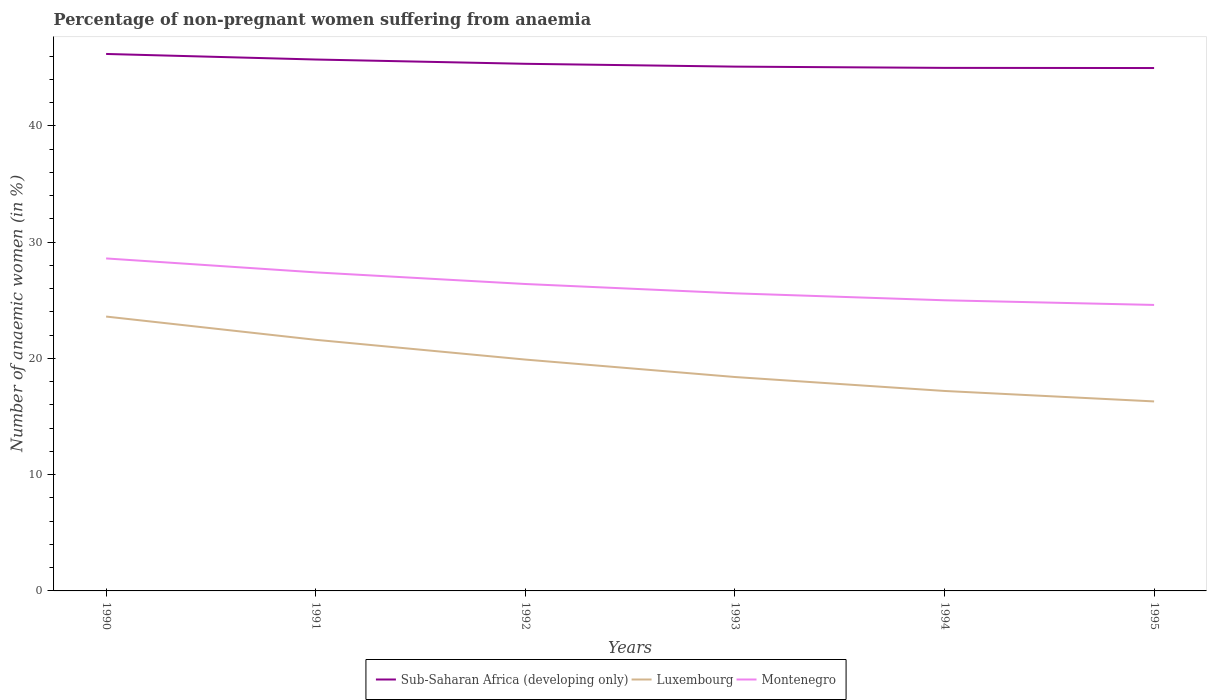Does the line corresponding to Luxembourg intersect with the line corresponding to Sub-Saharan Africa (developing only)?
Offer a terse response. No. Is the number of lines equal to the number of legend labels?
Keep it short and to the point. Yes. Across all years, what is the maximum percentage of non-pregnant women suffering from anaemia in Montenegro?
Ensure brevity in your answer.  24.6. What is the total percentage of non-pregnant women suffering from anaemia in Sub-Saharan Africa (developing only) in the graph?
Your answer should be compact. 0.35. What is the difference between the highest and the second highest percentage of non-pregnant women suffering from anaemia in Sub-Saharan Africa (developing only)?
Your answer should be very brief. 1.21. Is the percentage of non-pregnant women suffering from anaemia in Luxembourg strictly greater than the percentage of non-pregnant women suffering from anaemia in Montenegro over the years?
Your response must be concise. Yes. How many lines are there?
Your answer should be very brief. 3. Does the graph contain any zero values?
Keep it short and to the point. No. Does the graph contain grids?
Make the answer very short. No. Where does the legend appear in the graph?
Give a very brief answer. Bottom center. What is the title of the graph?
Offer a terse response. Percentage of non-pregnant women suffering from anaemia. What is the label or title of the Y-axis?
Offer a very short reply. Number of anaemic women (in %). What is the Number of anaemic women (in %) in Sub-Saharan Africa (developing only) in 1990?
Provide a succinct answer. 46.19. What is the Number of anaemic women (in %) in Luxembourg in 1990?
Offer a very short reply. 23.6. What is the Number of anaemic women (in %) of Montenegro in 1990?
Make the answer very short. 28.6. What is the Number of anaemic women (in %) of Sub-Saharan Africa (developing only) in 1991?
Provide a short and direct response. 45.71. What is the Number of anaemic women (in %) in Luxembourg in 1991?
Provide a succinct answer. 21.6. What is the Number of anaemic women (in %) in Montenegro in 1991?
Provide a short and direct response. 27.4. What is the Number of anaemic women (in %) in Sub-Saharan Africa (developing only) in 1992?
Keep it short and to the point. 45.34. What is the Number of anaemic women (in %) of Montenegro in 1992?
Your response must be concise. 26.4. What is the Number of anaemic women (in %) in Sub-Saharan Africa (developing only) in 1993?
Keep it short and to the point. 45.1. What is the Number of anaemic women (in %) of Luxembourg in 1993?
Ensure brevity in your answer.  18.4. What is the Number of anaemic women (in %) of Montenegro in 1993?
Keep it short and to the point. 25.6. What is the Number of anaemic women (in %) of Sub-Saharan Africa (developing only) in 1994?
Provide a short and direct response. 44.99. What is the Number of anaemic women (in %) in Sub-Saharan Africa (developing only) in 1995?
Offer a very short reply. 44.98. What is the Number of anaemic women (in %) of Luxembourg in 1995?
Keep it short and to the point. 16.3. What is the Number of anaemic women (in %) in Montenegro in 1995?
Provide a short and direct response. 24.6. Across all years, what is the maximum Number of anaemic women (in %) in Sub-Saharan Africa (developing only)?
Your answer should be compact. 46.19. Across all years, what is the maximum Number of anaemic women (in %) in Luxembourg?
Offer a terse response. 23.6. Across all years, what is the maximum Number of anaemic women (in %) of Montenegro?
Provide a succinct answer. 28.6. Across all years, what is the minimum Number of anaemic women (in %) in Sub-Saharan Africa (developing only)?
Provide a short and direct response. 44.98. Across all years, what is the minimum Number of anaemic women (in %) of Montenegro?
Keep it short and to the point. 24.6. What is the total Number of anaemic women (in %) of Sub-Saharan Africa (developing only) in the graph?
Provide a short and direct response. 272.31. What is the total Number of anaemic women (in %) in Luxembourg in the graph?
Offer a terse response. 117. What is the total Number of anaemic women (in %) of Montenegro in the graph?
Your answer should be very brief. 157.6. What is the difference between the Number of anaemic women (in %) in Sub-Saharan Africa (developing only) in 1990 and that in 1991?
Your answer should be very brief. 0.48. What is the difference between the Number of anaemic women (in %) of Luxembourg in 1990 and that in 1991?
Provide a succinct answer. 2. What is the difference between the Number of anaemic women (in %) in Montenegro in 1990 and that in 1991?
Offer a terse response. 1.2. What is the difference between the Number of anaemic women (in %) in Sub-Saharan Africa (developing only) in 1990 and that in 1992?
Your response must be concise. 0.85. What is the difference between the Number of anaemic women (in %) of Luxembourg in 1990 and that in 1992?
Keep it short and to the point. 3.7. What is the difference between the Number of anaemic women (in %) in Sub-Saharan Africa (developing only) in 1990 and that in 1993?
Your response must be concise. 1.09. What is the difference between the Number of anaemic women (in %) in Luxembourg in 1990 and that in 1993?
Give a very brief answer. 5.2. What is the difference between the Number of anaemic women (in %) in Montenegro in 1990 and that in 1993?
Your answer should be very brief. 3. What is the difference between the Number of anaemic women (in %) of Sub-Saharan Africa (developing only) in 1990 and that in 1994?
Provide a succinct answer. 1.2. What is the difference between the Number of anaemic women (in %) of Montenegro in 1990 and that in 1994?
Offer a very short reply. 3.6. What is the difference between the Number of anaemic women (in %) of Sub-Saharan Africa (developing only) in 1990 and that in 1995?
Your response must be concise. 1.21. What is the difference between the Number of anaemic women (in %) in Luxembourg in 1990 and that in 1995?
Provide a succinct answer. 7.3. What is the difference between the Number of anaemic women (in %) of Sub-Saharan Africa (developing only) in 1991 and that in 1992?
Give a very brief answer. 0.37. What is the difference between the Number of anaemic women (in %) of Sub-Saharan Africa (developing only) in 1991 and that in 1993?
Offer a terse response. 0.61. What is the difference between the Number of anaemic women (in %) in Luxembourg in 1991 and that in 1993?
Give a very brief answer. 3.2. What is the difference between the Number of anaemic women (in %) in Montenegro in 1991 and that in 1993?
Provide a short and direct response. 1.8. What is the difference between the Number of anaemic women (in %) in Sub-Saharan Africa (developing only) in 1991 and that in 1994?
Your response must be concise. 0.72. What is the difference between the Number of anaemic women (in %) of Luxembourg in 1991 and that in 1994?
Your answer should be compact. 4.4. What is the difference between the Number of anaemic women (in %) in Sub-Saharan Africa (developing only) in 1991 and that in 1995?
Your answer should be very brief. 0.73. What is the difference between the Number of anaemic women (in %) in Luxembourg in 1991 and that in 1995?
Offer a very short reply. 5.3. What is the difference between the Number of anaemic women (in %) in Sub-Saharan Africa (developing only) in 1992 and that in 1993?
Your answer should be compact. 0.24. What is the difference between the Number of anaemic women (in %) of Sub-Saharan Africa (developing only) in 1992 and that in 1994?
Offer a very short reply. 0.35. What is the difference between the Number of anaemic women (in %) of Luxembourg in 1992 and that in 1994?
Keep it short and to the point. 2.7. What is the difference between the Number of anaemic women (in %) in Montenegro in 1992 and that in 1994?
Your answer should be very brief. 1.4. What is the difference between the Number of anaemic women (in %) in Sub-Saharan Africa (developing only) in 1992 and that in 1995?
Provide a short and direct response. 0.36. What is the difference between the Number of anaemic women (in %) in Sub-Saharan Africa (developing only) in 1993 and that in 1994?
Ensure brevity in your answer.  0.11. What is the difference between the Number of anaemic women (in %) in Luxembourg in 1993 and that in 1994?
Ensure brevity in your answer.  1.2. What is the difference between the Number of anaemic women (in %) of Sub-Saharan Africa (developing only) in 1993 and that in 1995?
Your response must be concise. 0.12. What is the difference between the Number of anaemic women (in %) of Luxembourg in 1993 and that in 1995?
Provide a succinct answer. 2.1. What is the difference between the Number of anaemic women (in %) in Montenegro in 1993 and that in 1995?
Your answer should be compact. 1. What is the difference between the Number of anaemic women (in %) of Sub-Saharan Africa (developing only) in 1994 and that in 1995?
Ensure brevity in your answer.  0.01. What is the difference between the Number of anaemic women (in %) of Montenegro in 1994 and that in 1995?
Provide a succinct answer. 0.4. What is the difference between the Number of anaemic women (in %) of Sub-Saharan Africa (developing only) in 1990 and the Number of anaemic women (in %) of Luxembourg in 1991?
Offer a terse response. 24.59. What is the difference between the Number of anaemic women (in %) in Sub-Saharan Africa (developing only) in 1990 and the Number of anaemic women (in %) in Montenegro in 1991?
Make the answer very short. 18.79. What is the difference between the Number of anaemic women (in %) of Luxembourg in 1990 and the Number of anaemic women (in %) of Montenegro in 1991?
Your answer should be very brief. -3.8. What is the difference between the Number of anaemic women (in %) of Sub-Saharan Africa (developing only) in 1990 and the Number of anaemic women (in %) of Luxembourg in 1992?
Give a very brief answer. 26.29. What is the difference between the Number of anaemic women (in %) of Sub-Saharan Africa (developing only) in 1990 and the Number of anaemic women (in %) of Montenegro in 1992?
Make the answer very short. 19.79. What is the difference between the Number of anaemic women (in %) of Luxembourg in 1990 and the Number of anaemic women (in %) of Montenegro in 1992?
Your response must be concise. -2.8. What is the difference between the Number of anaemic women (in %) in Sub-Saharan Africa (developing only) in 1990 and the Number of anaemic women (in %) in Luxembourg in 1993?
Offer a very short reply. 27.79. What is the difference between the Number of anaemic women (in %) in Sub-Saharan Africa (developing only) in 1990 and the Number of anaemic women (in %) in Montenegro in 1993?
Your response must be concise. 20.59. What is the difference between the Number of anaemic women (in %) of Sub-Saharan Africa (developing only) in 1990 and the Number of anaemic women (in %) of Luxembourg in 1994?
Ensure brevity in your answer.  28.99. What is the difference between the Number of anaemic women (in %) of Sub-Saharan Africa (developing only) in 1990 and the Number of anaemic women (in %) of Montenegro in 1994?
Your response must be concise. 21.19. What is the difference between the Number of anaemic women (in %) in Sub-Saharan Africa (developing only) in 1990 and the Number of anaemic women (in %) in Luxembourg in 1995?
Provide a short and direct response. 29.89. What is the difference between the Number of anaemic women (in %) in Sub-Saharan Africa (developing only) in 1990 and the Number of anaemic women (in %) in Montenegro in 1995?
Provide a succinct answer. 21.59. What is the difference between the Number of anaemic women (in %) of Luxembourg in 1990 and the Number of anaemic women (in %) of Montenegro in 1995?
Your answer should be compact. -1. What is the difference between the Number of anaemic women (in %) in Sub-Saharan Africa (developing only) in 1991 and the Number of anaemic women (in %) in Luxembourg in 1992?
Your answer should be compact. 25.81. What is the difference between the Number of anaemic women (in %) in Sub-Saharan Africa (developing only) in 1991 and the Number of anaemic women (in %) in Montenegro in 1992?
Offer a very short reply. 19.31. What is the difference between the Number of anaemic women (in %) in Luxembourg in 1991 and the Number of anaemic women (in %) in Montenegro in 1992?
Your answer should be very brief. -4.8. What is the difference between the Number of anaemic women (in %) in Sub-Saharan Africa (developing only) in 1991 and the Number of anaemic women (in %) in Luxembourg in 1993?
Ensure brevity in your answer.  27.31. What is the difference between the Number of anaemic women (in %) of Sub-Saharan Africa (developing only) in 1991 and the Number of anaemic women (in %) of Montenegro in 1993?
Ensure brevity in your answer.  20.11. What is the difference between the Number of anaemic women (in %) of Luxembourg in 1991 and the Number of anaemic women (in %) of Montenegro in 1993?
Your response must be concise. -4. What is the difference between the Number of anaemic women (in %) of Sub-Saharan Africa (developing only) in 1991 and the Number of anaemic women (in %) of Luxembourg in 1994?
Your response must be concise. 28.51. What is the difference between the Number of anaemic women (in %) in Sub-Saharan Africa (developing only) in 1991 and the Number of anaemic women (in %) in Montenegro in 1994?
Offer a terse response. 20.71. What is the difference between the Number of anaemic women (in %) of Sub-Saharan Africa (developing only) in 1991 and the Number of anaemic women (in %) of Luxembourg in 1995?
Ensure brevity in your answer.  29.41. What is the difference between the Number of anaemic women (in %) in Sub-Saharan Africa (developing only) in 1991 and the Number of anaemic women (in %) in Montenegro in 1995?
Your answer should be compact. 21.11. What is the difference between the Number of anaemic women (in %) of Sub-Saharan Africa (developing only) in 1992 and the Number of anaemic women (in %) of Luxembourg in 1993?
Give a very brief answer. 26.94. What is the difference between the Number of anaemic women (in %) of Sub-Saharan Africa (developing only) in 1992 and the Number of anaemic women (in %) of Montenegro in 1993?
Your answer should be very brief. 19.74. What is the difference between the Number of anaemic women (in %) of Sub-Saharan Africa (developing only) in 1992 and the Number of anaemic women (in %) of Luxembourg in 1994?
Provide a succinct answer. 28.14. What is the difference between the Number of anaemic women (in %) in Sub-Saharan Africa (developing only) in 1992 and the Number of anaemic women (in %) in Montenegro in 1994?
Your answer should be very brief. 20.34. What is the difference between the Number of anaemic women (in %) in Luxembourg in 1992 and the Number of anaemic women (in %) in Montenegro in 1994?
Offer a terse response. -5.1. What is the difference between the Number of anaemic women (in %) of Sub-Saharan Africa (developing only) in 1992 and the Number of anaemic women (in %) of Luxembourg in 1995?
Your answer should be very brief. 29.04. What is the difference between the Number of anaemic women (in %) of Sub-Saharan Africa (developing only) in 1992 and the Number of anaemic women (in %) of Montenegro in 1995?
Make the answer very short. 20.74. What is the difference between the Number of anaemic women (in %) in Sub-Saharan Africa (developing only) in 1993 and the Number of anaemic women (in %) in Luxembourg in 1994?
Your answer should be compact. 27.9. What is the difference between the Number of anaemic women (in %) of Sub-Saharan Africa (developing only) in 1993 and the Number of anaemic women (in %) of Montenegro in 1994?
Give a very brief answer. 20.1. What is the difference between the Number of anaemic women (in %) of Sub-Saharan Africa (developing only) in 1993 and the Number of anaemic women (in %) of Luxembourg in 1995?
Offer a very short reply. 28.8. What is the difference between the Number of anaemic women (in %) of Sub-Saharan Africa (developing only) in 1993 and the Number of anaemic women (in %) of Montenegro in 1995?
Offer a very short reply. 20.5. What is the difference between the Number of anaemic women (in %) in Luxembourg in 1993 and the Number of anaemic women (in %) in Montenegro in 1995?
Your response must be concise. -6.2. What is the difference between the Number of anaemic women (in %) of Sub-Saharan Africa (developing only) in 1994 and the Number of anaemic women (in %) of Luxembourg in 1995?
Ensure brevity in your answer.  28.69. What is the difference between the Number of anaemic women (in %) in Sub-Saharan Africa (developing only) in 1994 and the Number of anaemic women (in %) in Montenegro in 1995?
Your answer should be very brief. 20.39. What is the difference between the Number of anaemic women (in %) in Luxembourg in 1994 and the Number of anaemic women (in %) in Montenegro in 1995?
Provide a short and direct response. -7.4. What is the average Number of anaemic women (in %) in Sub-Saharan Africa (developing only) per year?
Make the answer very short. 45.38. What is the average Number of anaemic women (in %) in Luxembourg per year?
Make the answer very short. 19.5. What is the average Number of anaemic women (in %) in Montenegro per year?
Give a very brief answer. 26.27. In the year 1990, what is the difference between the Number of anaemic women (in %) in Sub-Saharan Africa (developing only) and Number of anaemic women (in %) in Luxembourg?
Give a very brief answer. 22.59. In the year 1990, what is the difference between the Number of anaemic women (in %) of Sub-Saharan Africa (developing only) and Number of anaemic women (in %) of Montenegro?
Give a very brief answer. 17.59. In the year 1991, what is the difference between the Number of anaemic women (in %) of Sub-Saharan Africa (developing only) and Number of anaemic women (in %) of Luxembourg?
Offer a very short reply. 24.11. In the year 1991, what is the difference between the Number of anaemic women (in %) of Sub-Saharan Africa (developing only) and Number of anaemic women (in %) of Montenegro?
Your response must be concise. 18.31. In the year 1991, what is the difference between the Number of anaemic women (in %) of Luxembourg and Number of anaemic women (in %) of Montenegro?
Provide a short and direct response. -5.8. In the year 1992, what is the difference between the Number of anaemic women (in %) in Sub-Saharan Africa (developing only) and Number of anaemic women (in %) in Luxembourg?
Give a very brief answer. 25.44. In the year 1992, what is the difference between the Number of anaemic women (in %) in Sub-Saharan Africa (developing only) and Number of anaemic women (in %) in Montenegro?
Give a very brief answer. 18.94. In the year 1992, what is the difference between the Number of anaemic women (in %) of Luxembourg and Number of anaemic women (in %) of Montenegro?
Give a very brief answer. -6.5. In the year 1993, what is the difference between the Number of anaemic women (in %) of Sub-Saharan Africa (developing only) and Number of anaemic women (in %) of Luxembourg?
Provide a short and direct response. 26.7. In the year 1993, what is the difference between the Number of anaemic women (in %) of Sub-Saharan Africa (developing only) and Number of anaemic women (in %) of Montenegro?
Your answer should be compact. 19.5. In the year 1993, what is the difference between the Number of anaemic women (in %) in Luxembourg and Number of anaemic women (in %) in Montenegro?
Ensure brevity in your answer.  -7.2. In the year 1994, what is the difference between the Number of anaemic women (in %) in Sub-Saharan Africa (developing only) and Number of anaemic women (in %) in Luxembourg?
Ensure brevity in your answer.  27.79. In the year 1994, what is the difference between the Number of anaemic women (in %) in Sub-Saharan Africa (developing only) and Number of anaemic women (in %) in Montenegro?
Keep it short and to the point. 19.99. In the year 1994, what is the difference between the Number of anaemic women (in %) in Luxembourg and Number of anaemic women (in %) in Montenegro?
Provide a short and direct response. -7.8. In the year 1995, what is the difference between the Number of anaemic women (in %) of Sub-Saharan Africa (developing only) and Number of anaemic women (in %) of Luxembourg?
Your response must be concise. 28.68. In the year 1995, what is the difference between the Number of anaemic women (in %) in Sub-Saharan Africa (developing only) and Number of anaemic women (in %) in Montenegro?
Provide a short and direct response. 20.38. In the year 1995, what is the difference between the Number of anaemic women (in %) in Luxembourg and Number of anaemic women (in %) in Montenegro?
Keep it short and to the point. -8.3. What is the ratio of the Number of anaemic women (in %) of Sub-Saharan Africa (developing only) in 1990 to that in 1991?
Offer a very short reply. 1.01. What is the ratio of the Number of anaemic women (in %) of Luxembourg in 1990 to that in 1991?
Offer a very short reply. 1.09. What is the ratio of the Number of anaemic women (in %) in Montenegro in 1990 to that in 1991?
Your response must be concise. 1.04. What is the ratio of the Number of anaemic women (in %) of Sub-Saharan Africa (developing only) in 1990 to that in 1992?
Your answer should be very brief. 1.02. What is the ratio of the Number of anaemic women (in %) in Luxembourg in 1990 to that in 1992?
Your response must be concise. 1.19. What is the ratio of the Number of anaemic women (in %) in Montenegro in 1990 to that in 1992?
Your answer should be compact. 1.08. What is the ratio of the Number of anaemic women (in %) of Sub-Saharan Africa (developing only) in 1990 to that in 1993?
Ensure brevity in your answer.  1.02. What is the ratio of the Number of anaemic women (in %) of Luxembourg in 1990 to that in 1993?
Your response must be concise. 1.28. What is the ratio of the Number of anaemic women (in %) of Montenegro in 1990 to that in 1993?
Ensure brevity in your answer.  1.12. What is the ratio of the Number of anaemic women (in %) of Sub-Saharan Africa (developing only) in 1990 to that in 1994?
Provide a short and direct response. 1.03. What is the ratio of the Number of anaemic women (in %) of Luxembourg in 1990 to that in 1994?
Give a very brief answer. 1.37. What is the ratio of the Number of anaemic women (in %) of Montenegro in 1990 to that in 1994?
Make the answer very short. 1.14. What is the ratio of the Number of anaemic women (in %) in Sub-Saharan Africa (developing only) in 1990 to that in 1995?
Give a very brief answer. 1.03. What is the ratio of the Number of anaemic women (in %) in Luxembourg in 1990 to that in 1995?
Give a very brief answer. 1.45. What is the ratio of the Number of anaemic women (in %) of Montenegro in 1990 to that in 1995?
Make the answer very short. 1.16. What is the ratio of the Number of anaemic women (in %) in Luxembourg in 1991 to that in 1992?
Provide a short and direct response. 1.09. What is the ratio of the Number of anaemic women (in %) of Montenegro in 1991 to that in 1992?
Your answer should be compact. 1.04. What is the ratio of the Number of anaemic women (in %) in Sub-Saharan Africa (developing only) in 1991 to that in 1993?
Keep it short and to the point. 1.01. What is the ratio of the Number of anaemic women (in %) of Luxembourg in 1991 to that in 1993?
Provide a succinct answer. 1.17. What is the ratio of the Number of anaemic women (in %) in Montenegro in 1991 to that in 1993?
Provide a succinct answer. 1.07. What is the ratio of the Number of anaemic women (in %) in Luxembourg in 1991 to that in 1994?
Make the answer very short. 1.26. What is the ratio of the Number of anaemic women (in %) of Montenegro in 1991 to that in 1994?
Provide a succinct answer. 1.1. What is the ratio of the Number of anaemic women (in %) of Sub-Saharan Africa (developing only) in 1991 to that in 1995?
Provide a short and direct response. 1.02. What is the ratio of the Number of anaemic women (in %) of Luxembourg in 1991 to that in 1995?
Keep it short and to the point. 1.33. What is the ratio of the Number of anaemic women (in %) in Montenegro in 1991 to that in 1995?
Provide a short and direct response. 1.11. What is the ratio of the Number of anaemic women (in %) of Sub-Saharan Africa (developing only) in 1992 to that in 1993?
Offer a very short reply. 1.01. What is the ratio of the Number of anaemic women (in %) of Luxembourg in 1992 to that in 1993?
Provide a short and direct response. 1.08. What is the ratio of the Number of anaemic women (in %) of Montenegro in 1992 to that in 1993?
Offer a terse response. 1.03. What is the ratio of the Number of anaemic women (in %) of Sub-Saharan Africa (developing only) in 1992 to that in 1994?
Your answer should be very brief. 1.01. What is the ratio of the Number of anaemic women (in %) of Luxembourg in 1992 to that in 1994?
Your answer should be very brief. 1.16. What is the ratio of the Number of anaemic women (in %) of Montenegro in 1992 to that in 1994?
Ensure brevity in your answer.  1.06. What is the ratio of the Number of anaemic women (in %) in Luxembourg in 1992 to that in 1995?
Offer a terse response. 1.22. What is the ratio of the Number of anaemic women (in %) in Montenegro in 1992 to that in 1995?
Ensure brevity in your answer.  1.07. What is the ratio of the Number of anaemic women (in %) in Luxembourg in 1993 to that in 1994?
Your answer should be compact. 1.07. What is the ratio of the Number of anaemic women (in %) in Sub-Saharan Africa (developing only) in 1993 to that in 1995?
Keep it short and to the point. 1. What is the ratio of the Number of anaemic women (in %) of Luxembourg in 1993 to that in 1995?
Keep it short and to the point. 1.13. What is the ratio of the Number of anaemic women (in %) of Montenegro in 1993 to that in 1995?
Your answer should be compact. 1.04. What is the ratio of the Number of anaemic women (in %) of Luxembourg in 1994 to that in 1995?
Your response must be concise. 1.06. What is the ratio of the Number of anaemic women (in %) in Montenegro in 1994 to that in 1995?
Keep it short and to the point. 1.02. What is the difference between the highest and the second highest Number of anaemic women (in %) of Sub-Saharan Africa (developing only)?
Your answer should be compact. 0.48. What is the difference between the highest and the lowest Number of anaemic women (in %) of Sub-Saharan Africa (developing only)?
Keep it short and to the point. 1.21. What is the difference between the highest and the lowest Number of anaemic women (in %) of Luxembourg?
Provide a succinct answer. 7.3. 